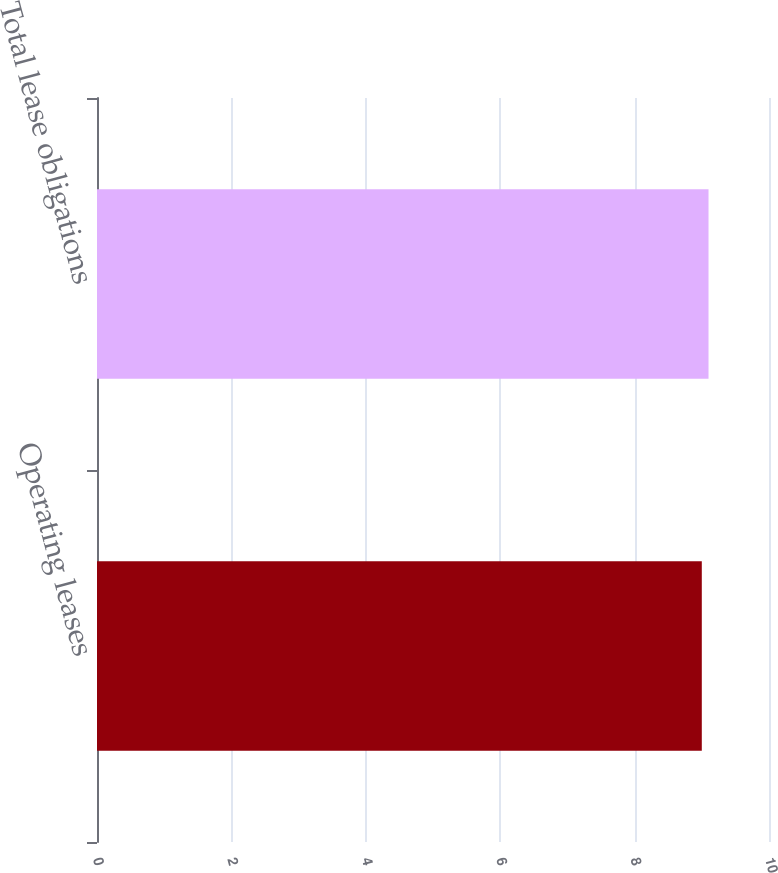Convert chart to OTSL. <chart><loc_0><loc_0><loc_500><loc_500><bar_chart><fcel>Operating leases<fcel>Total lease obligations<nl><fcel>9<fcel>9.1<nl></chart> 